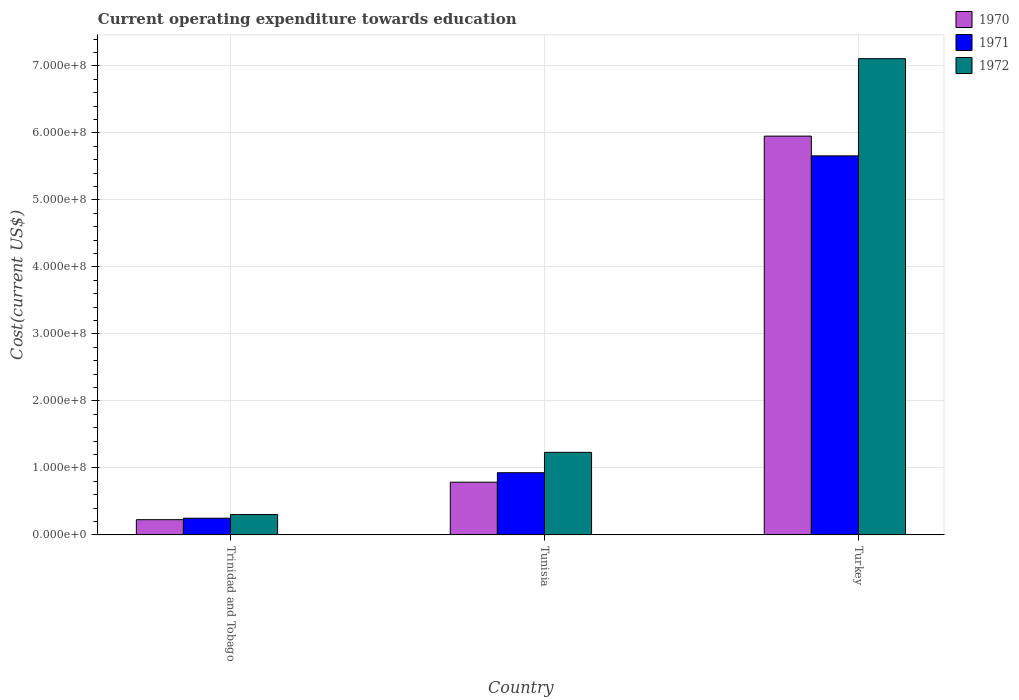In how many cases, is the number of bars for a given country not equal to the number of legend labels?
Give a very brief answer. 0. What is the expenditure towards education in 1971 in Turkey?
Give a very brief answer. 5.66e+08. Across all countries, what is the maximum expenditure towards education in 1970?
Provide a succinct answer. 5.95e+08. Across all countries, what is the minimum expenditure towards education in 1970?
Your answer should be compact. 2.27e+07. In which country was the expenditure towards education in 1971 minimum?
Offer a terse response. Trinidad and Tobago. What is the total expenditure towards education in 1972 in the graph?
Make the answer very short. 8.65e+08. What is the difference between the expenditure towards education in 1970 in Trinidad and Tobago and that in Turkey?
Make the answer very short. -5.73e+08. What is the difference between the expenditure towards education in 1972 in Turkey and the expenditure towards education in 1970 in Tunisia?
Make the answer very short. 6.32e+08. What is the average expenditure towards education in 1970 per country?
Make the answer very short. 2.32e+08. What is the difference between the expenditure towards education of/in 1972 and expenditure towards education of/in 1971 in Trinidad and Tobago?
Your answer should be very brief. 5.48e+06. What is the ratio of the expenditure towards education in 1972 in Trinidad and Tobago to that in Tunisia?
Provide a succinct answer. 0.25. Is the difference between the expenditure towards education in 1972 in Trinidad and Tobago and Turkey greater than the difference between the expenditure towards education in 1971 in Trinidad and Tobago and Turkey?
Your answer should be very brief. No. What is the difference between the highest and the second highest expenditure towards education in 1972?
Make the answer very short. 5.88e+08. What is the difference between the highest and the lowest expenditure towards education in 1972?
Provide a succinct answer. 6.81e+08. In how many countries, is the expenditure towards education in 1972 greater than the average expenditure towards education in 1972 taken over all countries?
Your response must be concise. 1. What does the 1st bar from the left in Tunisia represents?
Offer a very short reply. 1970. What does the 2nd bar from the right in Turkey represents?
Give a very brief answer. 1971. What is the difference between two consecutive major ticks on the Y-axis?
Offer a terse response. 1.00e+08. Are the values on the major ticks of Y-axis written in scientific E-notation?
Provide a succinct answer. Yes. Does the graph contain any zero values?
Ensure brevity in your answer.  No. How many legend labels are there?
Your answer should be very brief. 3. What is the title of the graph?
Offer a very short reply. Current operating expenditure towards education. Does "2009" appear as one of the legend labels in the graph?
Give a very brief answer. No. What is the label or title of the X-axis?
Make the answer very short. Country. What is the label or title of the Y-axis?
Give a very brief answer. Cost(current US$). What is the Cost(current US$) of 1970 in Trinidad and Tobago?
Ensure brevity in your answer.  2.27e+07. What is the Cost(current US$) in 1971 in Trinidad and Tobago?
Your answer should be very brief. 2.49e+07. What is the Cost(current US$) of 1972 in Trinidad and Tobago?
Give a very brief answer. 3.04e+07. What is the Cost(current US$) of 1970 in Tunisia?
Your answer should be very brief. 7.87e+07. What is the Cost(current US$) in 1971 in Tunisia?
Keep it short and to the point. 9.28e+07. What is the Cost(current US$) in 1972 in Tunisia?
Keep it short and to the point. 1.23e+08. What is the Cost(current US$) of 1970 in Turkey?
Keep it short and to the point. 5.95e+08. What is the Cost(current US$) of 1971 in Turkey?
Provide a succinct answer. 5.66e+08. What is the Cost(current US$) of 1972 in Turkey?
Your answer should be very brief. 7.11e+08. Across all countries, what is the maximum Cost(current US$) of 1970?
Offer a terse response. 5.95e+08. Across all countries, what is the maximum Cost(current US$) of 1971?
Your answer should be very brief. 5.66e+08. Across all countries, what is the maximum Cost(current US$) of 1972?
Your answer should be very brief. 7.11e+08. Across all countries, what is the minimum Cost(current US$) in 1970?
Provide a succinct answer. 2.27e+07. Across all countries, what is the minimum Cost(current US$) in 1971?
Provide a short and direct response. 2.49e+07. Across all countries, what is the minimum Cost(current US$) of 1972?
Offer a very short reply. 3.04e+07. What is the total Cost(current US$) of 1970 in the graph?
Ensure brevity in your answer.  6.97e+08. What is the total Cost(current US$) in 1971 in the graph?
Give a very brief answer. 6.84e+08. What is the total Cost(current US$) of 1972 in the graph?
Give a very brief answer. 8.65e+08. What is the difference between the Cost(current US$) of 1970 in Trinidad and Tobago and that in Tunisia?
Your response must be concise. -5.60e+07. What is the difference between the Cost(current US$) of 1971 in Trinidad and Tobago and that in Tunisia?
Your answer should be compact. -6.79e+07. What is the difference between the Cost(current US$) in 1972 in Trinidad and Tobago and that in Tunisia?
Provide a short and direct response. -9.29e+07. What is the difference between the Cost(current US$) of 1970 in Trinidad and Tobago and that in Turkey?
Give a very brief answer. -5.73e+08. What is the difference between the Cost(current US$) of 1971 in Trinidad and Tobago and that in Turkey?
Your response must be concise. -5.41e+08. What is the difference between the Cost(current US$) in 1972 in Trinidad and Tobago and that in Turkey?
Provide a succinct answer. -6.81e+08. What is the difference between the Cost(current US$) in 1970 in Tunisia and that in Turkey?
Keep it short and to the point. -5.17e+08. What is the difference between the Cost(current US$) of 1971 in Tunisia and that in Turkey?
Keep it short and to the point. -4.73e+08. What is the difference between the Cost(current US$) in 1972 in Tunisia and that in Turkey?
Your response must be concise. -5.88e+08. What is the difference between the Cost(current US$) of 1970 in Trinidad and Tobago and the Cost(current US$) of 1971 in Tunisia?
Keep it short and to the point. -7.01e+07. What is the difference between the Cost(current US$) of 1970 in Trinidad and Tobago and the Cost(current US$) of 1972 in Tunisia?
Provide a succinct answer. -1.01e+08. What is the difference between the Cost(current US$) in 1971 in Trinidad and Tobago and the Cost(current US$) in 1972 in Tunisia?
Offer a terse response. -9.83e+07. What is the difference between the Cost(current US$) in 1970 in Trinidad and Tobago and the Cost(current US$) in 1971 in Turkey?
Provide a succinct answer. -5.43e+08. What is the difference between the Cost(current US$) in 1970 in Trinidad and Tobago and the Cost(current US$) in 1972 in Turkey?
Give a very brief answer. -6.88e+08. What is the difference between the Cost(current US$) in 1971 in Trinidad and Tobago and the Cost(current US$) in 1972 in Turkey?
Give a very brief answer. -6.86e+08. What is the difference between the Cost(current US$) in 1970 in Tunisia and the Cost(current US$) in 1971 in Turkey?
Provide a short and direct response. -4.87e+08. What is the difference between the Cost(current US$) of 1970 in Tunisia and the Cost(current US$) of 1972 in Turkey?
Your response must be concise. -6.32e+08. What is the difference between the Cost(current US$) of 1971 in Tunisia and the Cost(current US$) of 1972 in Turkey?
Make the answer very short. -6.18e+08. What is the average Cost(current US$) of 1970 per country?
Offer a very short reply. 2.32e+08. What is the average Cost(current US$) in 1971 per country?
Your answer should be very brief. 2.28e+08. What is the average Cost(current US$) of 1972 per country?
Your answer should be compact. 2.88e+08. What is the difference between the Cost(current US$) of 1970 and Cost(current US$) of 1971 in Trinidad and Tobago?
Your answer should be very brief. -2.19e+06. What is the difference between the Cost(current US$) of 1970 and Cost(current US$) of 1972 in Trinidad and Tobago?
Keep it short and to the point. -7.68e+06. What is the difference between the Cost(current US$) of 1971 and Cost(current US$) of 1972 in Trinidad and Tobago?
Provide a succinct answer. -5.48e+06. What is the difference between the Cost(current US$) in 1970 and Cost(current US$) in 1971 in Tunisia?
Provide a short and direct response. -1.42e+07. What is the difference between the Cost(current US$) in 1970 and Cost(current US$) in 1972 in Tunisia?
Keep it short and to the point. -4.46e+07. What is the difference between the Cost(current US$) of 1971 and Cost(current US$) of 1972 in Tunisia?
Your answer should be very brief. -3.04e+07. What is the difference between the Cost(current US$) in 1970 and Cost(current US$) in 1971 in Turkey?
Offer a very short reply. 2.95e+07. What is the difference between the Cost(current US$) of 1970 and Cost(current US$) of 1972 in Turkey?
Ensure brevity in your answer.  -1.16e+08. What is the difference between the Cost(current US$) in 1971 and Cost(current US$) in 1972 in Turkey?
Make the answer very short. -1.45e+08. What is the ratio of the Cost(current US$) of 1970 in Trinidad and Tobago to that in Tunisia?
Provide a succinct answer. 0.29. What is the ratio of the Cost(current US$) in 1971 in Trinidad and Tobago to that in Tunisia?
Your answer should be compact. 0.27. What is the ratio of the Cost(current US$) of 1972 in Trinidad and Tobago to that in Tunisia?
Your answer should be very brief. 0.25. What is the ratio of the Cost(current US$) in 1970 in Trinidad and Tobago to that in Turkey?
Offer a terse response. 0.04. What is the ratio of the Cost(current US$) in 1971 in Trinidad and Tobago to that in Turkey?
Provide a short and direct response. 0.04. What is the ratio of the Cost(current US$) of 1972 in Trinidad and Tobago to that in Turkey?
Your response must be concise. 0.04. What is the ratio of the Cost(current US$) of 1970 in Tunisia to that in Turkey?
Provide a succinct answer. 0.13. What is the ratio of the Cost(current US$) in 1971 in Tunisia to that in Turkey?
Make the answer very short. 0.16. What is the ratio of the Cost(current US$) in 1972 in Tunisia to that in Turkey?
Give a very brief answer. 0.17. What is the difference between the highest and the second highest Cost(current US$) in 1970?
Your answer should be compact. 5.17e+08. What is the difference between the highest and the second highest Cost(current US$) in 1971?
Give a very brief answer. 4.73e+08. What is the difference between the highest and the second highest Cost(current US$) of 1972?
Provide a short and direct response. 5.88e+08. What is the difference between the highest and the lowest Cost(current US$) of 1970?
Keep it short and to the point. 5.73e+08. What is the difference between the highest and the lowest Cost(current US$) of 1971?
Offer a very short reply. 5.41e+08. What is the difference between the highest and the lowest Cost(current US$) of 1972?
Provide a short and direct response. 6.81e+08. 